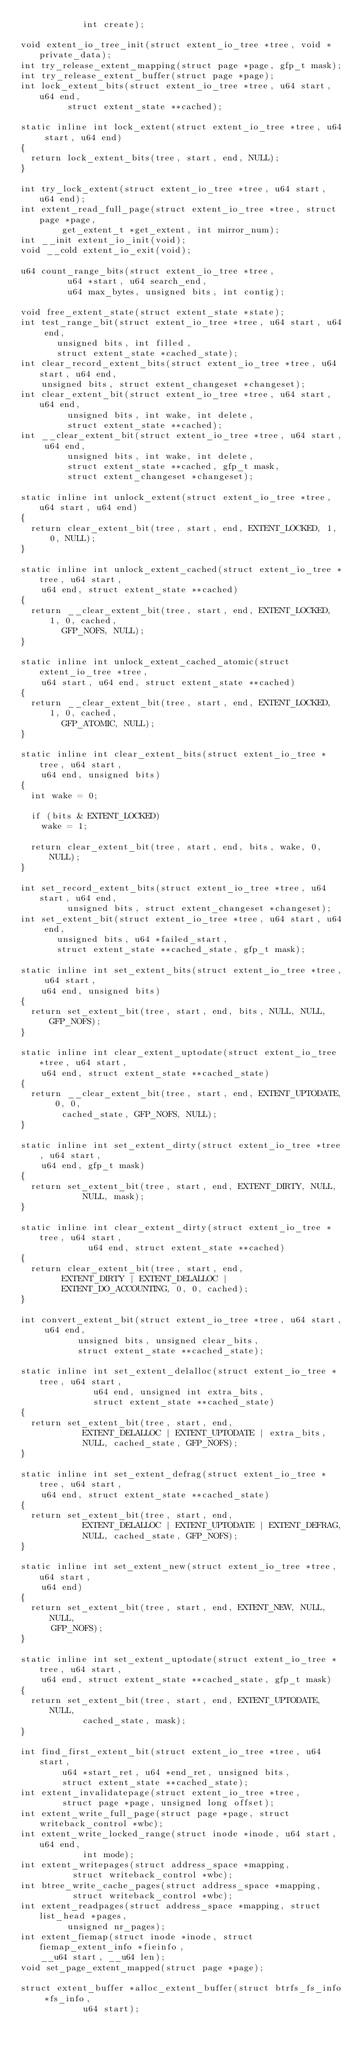<code> <loc_0><loc_0><loc_500><loc_500><_C_>					  int create);

void extent_io_tree_init(struct extent_io_tree *tree, void *private_data);
int try_release_extent_mapping(struct page *page, gfp_t mask);
int try_release_extent_buffer(struct page *page);
int lock_extent_bits(struct extent_io_tree *tree, u64 start, u64 end,
		     struct extent_state **cached);

static inline int lock_extent(struct extent_io_tree *tree, u64 start, u64 end)
{
	return lock_extent_bits(tree, start, end, NULL);
}

int try_lock_extent(struct extent_io_tree *tree, u64 start, u64 end);
int extent_read_full_page(struct extent_io_tree *tree, struct page *page,
			  get_extent_t *get_extent, int mirror_num);
int __init extent_io_init(void);
void __cold extent_io_exit(void);

u64 count_range_bits(struct extent_io_tree *tree,
		     u64 *start, u64 search_end,
		     u64 max_bytes, unsigned bits, int contig);

void free_extent_state(struct extent_state *state);
int test_range_bit(struct extent_io_tree *tree, u64 start, u64 end,
		   unsigned bits, int filled,
		   struct extent_state *cached_state);
int clear_record_extent_bits(struct extent_io_tree *tree, u64 start, u64 end,
		unsigned bits, struct extent_changeset *changeset);
int clear_extent_bit(struct extent_io_tree *tree, u64 start, u64 end,
		     unsigned bits, int wake, int delete,
		     struct extent_state **cached);
int __clear_extent_bit(struct extent_io_tree *tree, u64 start, u64 end,
		     unsigned bits, int wake, int delete,
		     struct extent_state **cached, gfp_t mask,
		     struct extent_changeset *changeset);

static inline int unlock_extent(struct extent_io_tree *tree, u64 start, u64 end)
{
	return clear_extent_bit(tree, start, end, EXTENT_LOCKED, 1, 0, NULL);
}

static inline int unlock_extent_cached(struct extent_io_tree *tree, u64 start,
		u64 end, struct extent_state **cached)
{
	return __clear_extent_bit(tree, start, end, EXTENT_LOCKED, 1, 0, cached,
				GFP_NOFS, NULL);
}

static inline int unlock_extent_cached_atomic(struct extent_io_tree *tree,
		u64 start, u64 end, struct extent_state **cached)
{
	return __clear_extent_bit(tree, start, end, EXTENT_LOCKED, 1, 0, cached,
				GFP_ATOMIC, NULL);
}

static inline int clear_extent_bits(struct extent_io_tree *tree, u64 start,
		u64 end, unsigned bits)
{
	int wake = 0;

	if (bits & EXTENT_LOCKED)
		wake = 1;

	return clear_extent_bit(tree, start, end, bits, wake, 0, NULL);
}

int set_record_extent_bits(struct extent_io_tree *tree, u64 start, u64 end,
			   unsigned bits, struct extent_changeset *changeset);
int set_extent_bit(struct extent_io_tree *tree, u64 start, u64 end,
		   unsigned bits, u64 *failed_start,
		   struct extent_state **cached_state, gfp_t mask);

static inline int set_extent_bits(struct extent_io_tree *tree, u64 start,
		u64 end, unsigned bits)
{
	return set_extent_bit(tree, start, end, bits, NULL, NULL, GFP_NOFS);
}

static inline int clear_extent_uptodate(struct extent_io_tree *tree, u64 start,
		u64 end, struct extent_state **cached_state)
{
	return __clear_extent_bit(tree, start, end, EXTENT_UPTODATE, 0, 0,
				cached_state, GFP_NOFS, NULL);
}

static inline int set_extent_dirty(struct extent_io_tree *tree, u64 start,
		u64 end, gfp_t mask)
{
	return set_extent_bit(tree, start, end, EXTENT_DIRTY, NULL,
			      NULL, mask);
}

static inline int clear_extent_dirty(struct extent_io_tree *tree, u64 start,
				     u64 end, struct extent_state **cached)
{
	return clear_extent_bit(tree, start, end,
				EXTENT_DIRTY | EXTENT_DELALLOC |
				EXTENT_DO_ACCOUNTING, 0, 0, cached);
}

int convert_extent_bit(struct extent_io_tree *tree, u64 start, u64 end,
		       unsigned bits, unsigned clear_bits,
		       struct extent_state **cached_state);

static inline int set_extent_delalloc(struct extent_io_tree *tree, u64 start,
				      u64 end, unsigned int extra_bits,
				      struct extent_state **cached_state)
{
	return set_extent_bit(tree, start, end,
			      EXTENT_DELALLOC | EXTENT_UPTODATE | extra_bits,
			      NULL, cached_state, GFP_NOFS);
}

static inline int set_extent_defrag(struct extent_io_tree *tree, u64 start,
		u64 end, struct extent_state **cached_state)
{
	return set_extent_bit(tree, start, end,
			      EXTENT_DELALLOC | EXTENT_UPTODATE | EXTENT_DEFRAG,
			      NULL, cached_state, GFP_NOFS);
}

static inline int set_extent_new(struct extent_io_tree *tree, u64 start,
		u64 end)
{
	return set_extent_bit(tree, start, end, EXTENT_NEW, NULL, NULL,
			GFP_NOFS);
}

static inline int set_extent_uptodate(struct extent_io_tree *tree, u64 start,
		u64 end, struct extent_state **cached_state, gfp_t mask)
{
	return set_extent_bit(tree, start, end, EXTENT_UPTODATE, NULL,
			      cached_state, mask);
}

int find_first_extent_bit(struct extent_io_tree *tree, u64 start,
			  u64 *start_ret, u64 *end_ret, unsigned bits,
			  struct extent_state **cached_state);
int extent_invalidatepage(struct extent_io_tree *tree,
			  struct page *page, unsigned long offset);
int extent_write_full_page(struct page *page, struct writeback_control *wbc);
int extent_write_locked_range(struct inode *inode, u64 start, u64 end,
			      int mode);
int extent_writepages(struct address_space *mapping,
		      struct writeback_control *wbc);
int btree_write_cache_pages(struct address_space *mapping,
			    struct writeback_control *wbc);
int extent_readpages(struct address_space *mapping, struct list_head *pages,
		     unsigned nr_pages);
int extent_fiemap(struct inode *inode, struct fiemap_extent_info *fieinfo,
		__u64 start, __u64 len);
void set_page_extent_mapped(struct page *page);

struct extent_buffer *alloc_extent_buffer(struct btrfs_fs_info *fs_info,
					  u64 start);</code> 